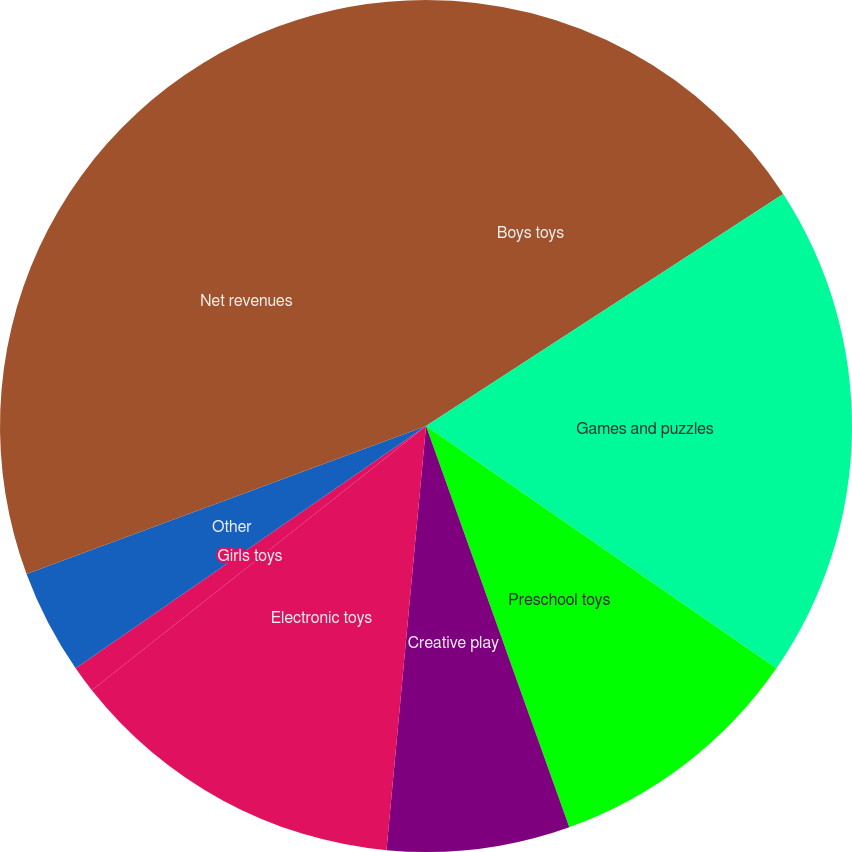Convert chart. <chart><loc_0><loc_0><loc_500><loc_500><pie_chart><fcel>Boys toys<fcel>Games and puzzles<fcel>Preschool toys<fcel>Creative play<fcel>Electronic toys<fcel>Girls toys<fcel>Other<fcel>Net revenues<nl><fcel>15.83%<fcel>18.8%<fcel>9.91%<fcel>6.94%<fcel>12.87%<fcel>1.02%<fcel>3.98%<fcel>30.65%<nl></chart> 